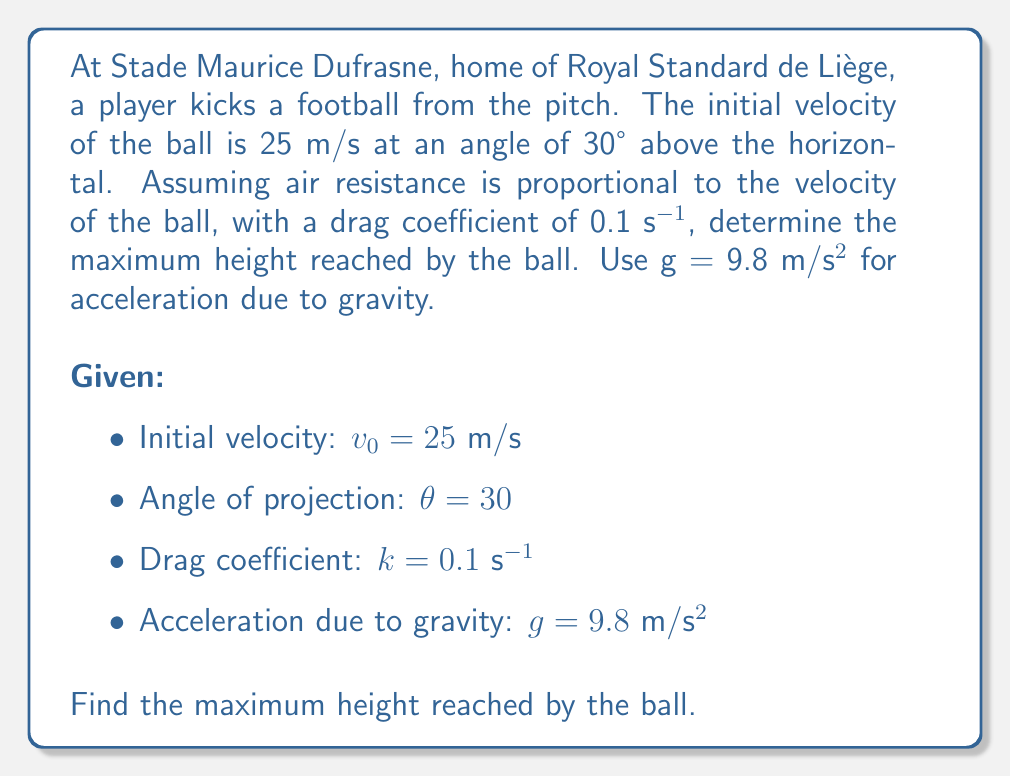Help me with this question. To solve this problem, we need to consider the vertical component of motion and use a first-order differential equation to account for air resistance.

1) First, let's break down the initial velocity into its components:
   $v_{0x} = v_0 \cos(\theta) = 25 \cos(30°) = 21.65$ m/s
   $v_{0y} = v_0 \sin(\theta) = 25 \sin(30°) = 12.5$ m/s

2) The differential equation for vertical motion with air resistance is:

   $$\frac{dv_y}{dt} = -g - kv_y$$

   where $v_y$ is the vertical velocity.

3) We can solve this differential equation:

   $$\frac{dv_y}{-g - kv_y} = dt$$
   $$\int \frac{dv_y}{-g - kv_y} = \int dt$$
   $$-\frac{1}{k} \ln|-g - kv_y| = t + C$$

4) Using the initial condition $v_y(0) = v_{0y} = 12.5$ m/s, we can find C:

   $$-\frac{1}{k} \ln|-g - kv_{0y}| = 0 + C$$
   $$C = -\frac{1}{k} \ln|-g - kv_{0y}|$$

5) Substituting back:

   $$-\frac{1}{k} \ln|-g - kv_y| = t - \frac{1}{k} \ln|-g - kv_{0y}|$$
   $$\ln|-g - kv_y| = \ln|-g - kv_{0y}| - kt$$
   $$-g - kv_y = (-g - kv_{0y})e^{-kt}$$
   $$v_y = \frac{g}{k}(e^{-kt} - 1) + v_{0y}e^{-kt}$$

6) To find the maximum height, we need to find when $v_y = 0$:

   $$0 = \frac{g}{k}(e^{-kt} - 1) + v_{0y}e^{-kt}$$
   $$\frac{g}{k}(1 - e^{-kt}) = v_{0y}e^{-kt}$$
   $$\frac{g}{k} = v_{0y}e^{-kt} + \frac{g}{k}e^{-kt}$$
   $$1 = (\frac{kv_{0y}}{g} + 1)e^{-kt}$$
   $$-kt = \ln(\frac{g}{kv_{0y} + g})$$
   $$t = -\frac{1}{k}\ln(\frac{g}{kv_{0y} + g})$$

7) Substituting the values:

   $$t = -\frac{1}{0.1}\ln(\frac{9.8}{0.1 \cdot 12.5 + 9.8}) = 1.087 \text{ s}$$

8) Now we can find the maximum height by integrating the velocity equation:

   $$y = \int_0^t v_y dt = \int_0^t [\frac{g}{k}(e^{-kt} - 1) + v_{0y}e^{-kt}] dt$$
   $$y = -\frac{g}{k^2}(e^{-kt} - 1) - \frac{v_{0y}}{k}e^{-kt} + (\frac{g}{k^2} - \frac{v_{0y}}{k})t$$

9) Substituting $t = 1.087$ and the given values:

   $$y = -\frac{9.8}{0.1^2}(e^{-0.1 \cdot 1.087} - 1) - \frac{12.5}{0.1}e^{-0.1 \cdot 1.087} + (\frac{9.8}{0.1^2} - \frac{12.5}{0.1}) \cdot 1.087$$
Answer: The maximum height reached by the ball is approximately 8.16 meters. 